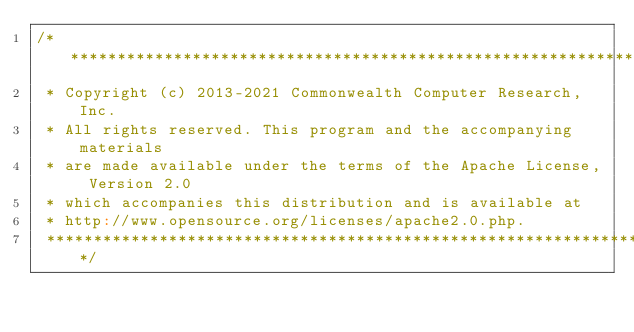<code> <loc_0><loc_0><loc_500><loc_500><_Scala_>/***********************************************************************
 * Copyright (c) 2013-2021 Commonwealth Computer Research, Inc.
 * All rights reserved. This program and the accompanying materials
 * are made available under the terms of the Apache License, Version 2.0
 * which accompanies this distribution and is available at
 * http://www.opensource.org/licenses/apache2.0.php.
 ***********************************************************************/
</code> 